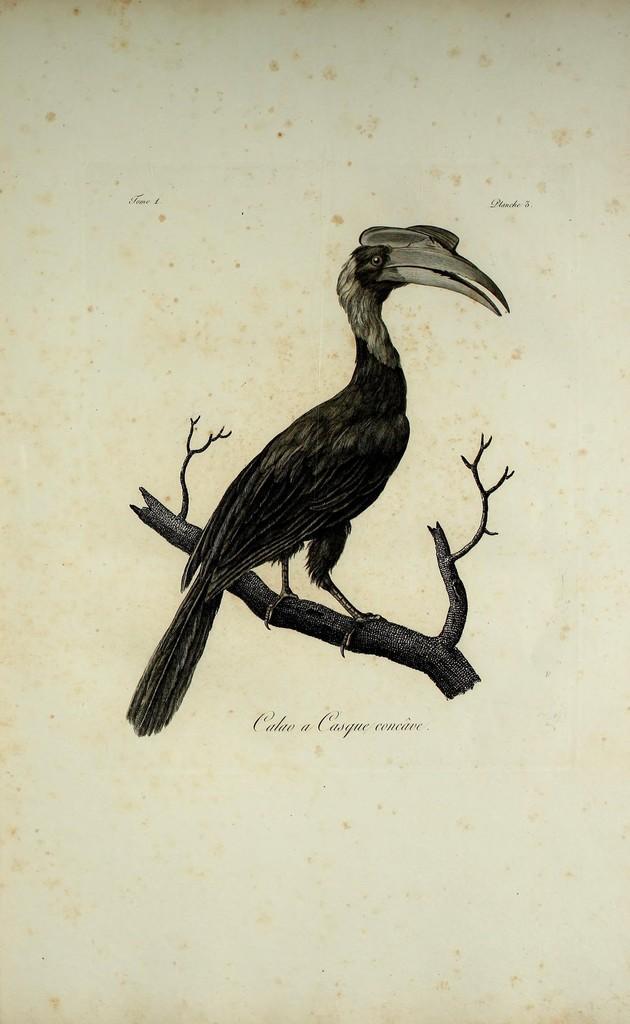Please provide a concise description of this image. In this image we can see a bird is standing on the branch. Something written under this branch and bird. 